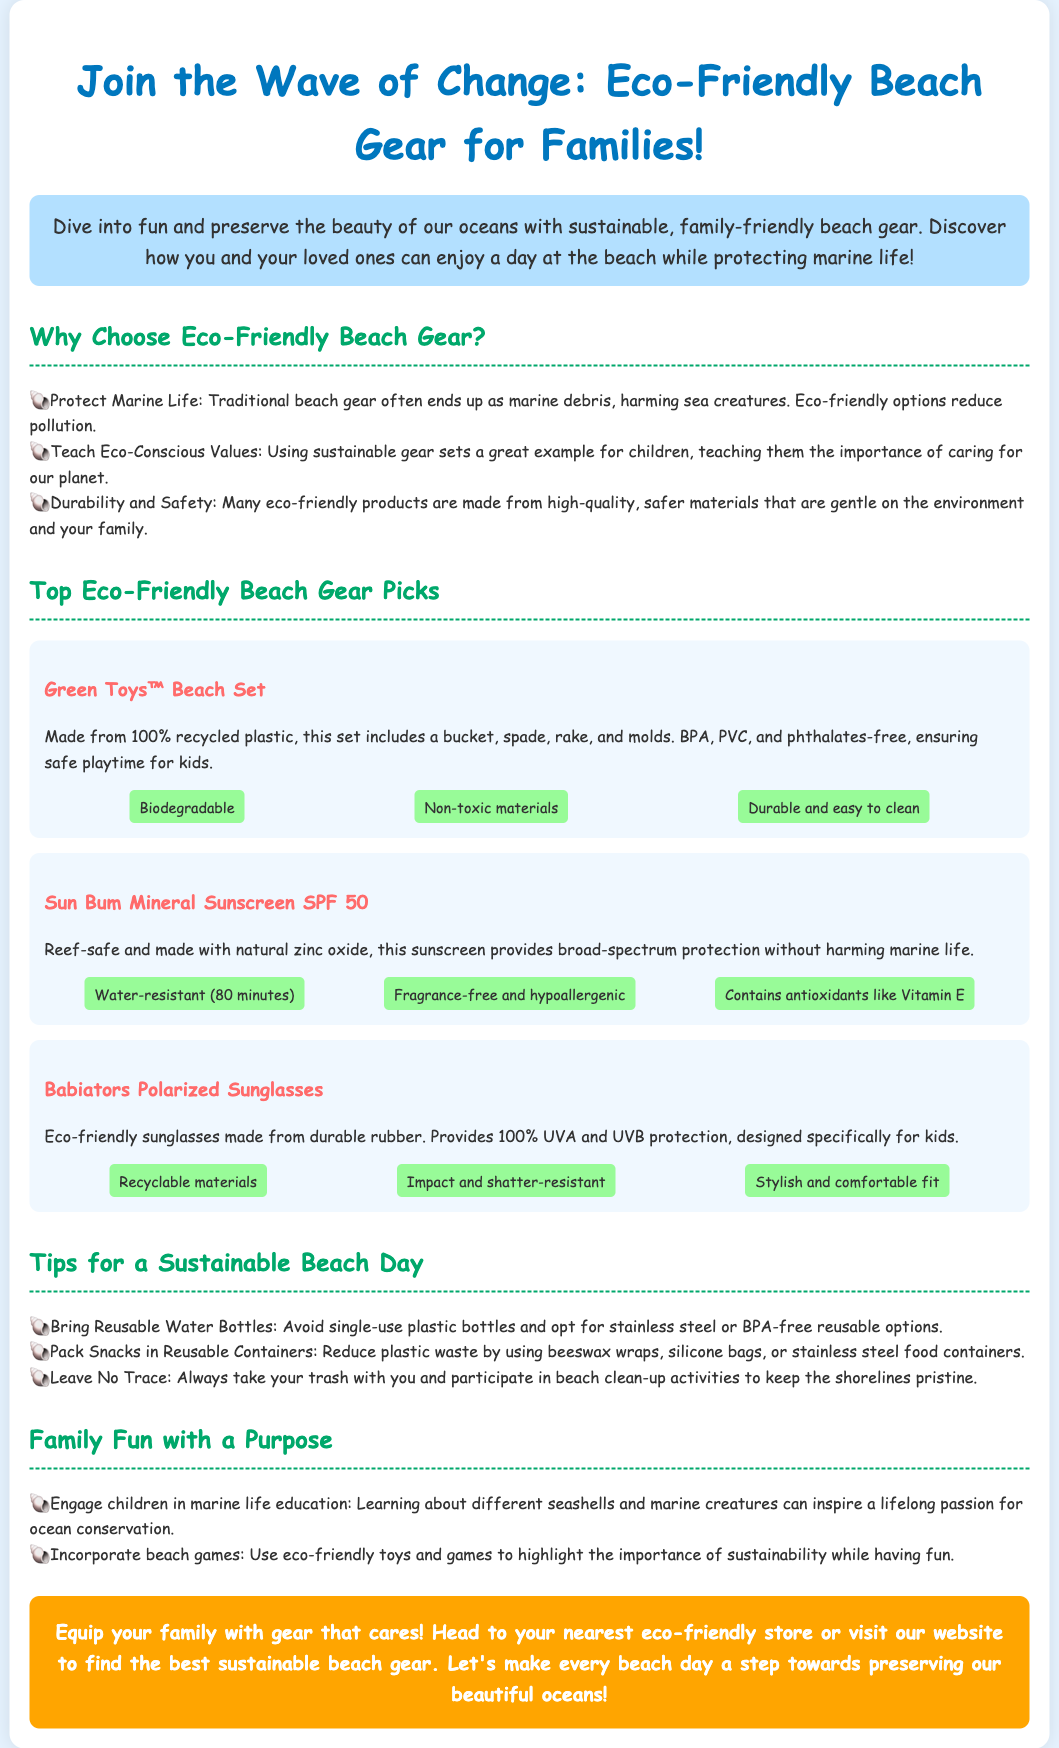What is the title of the advertisement? The title of the advertisement is found in the header and is specifically designed to grab attention regarding eco-friendly beach gear.
Answer: Eco-Friendly Beach Gear for Families What sunscreen is mentioned in the ad? The advertisement lists specific products, and this sunscreen is highlighted for its reef-safe quality.
Answer: Sun Bum Mineral Sunscreen SPF 50 How many benefits are listed for the Green Toys™ Beach Set? The benefits of the product are directly stated in the advertisement, specifically for this beach set.
Answer: Three What material are the Babiators Polarized Sunglasses made from? The advertisement specifies the type of materials used in making the sunglasses.
Answer: Durable rubber What is one of the tips for a sustainable beach day? The document provides practical advice for families on how to engage in sustainable practices during their beach outings.
Answer: Bring Reusable Water Bottles Why should families choose eco-friendly beach gear? The document outlines several reasons for selecting eco-friendly options, focusing on their impact on the environment and teaching values.
Answer: Protect Marine Life What is the color of the call-to-action section? The advertisement designates a specific color for the call-to-action section to make it standout visually among the other sections.
Answer: Orange How long is the Sun Bum Mineral Sunscreen water-resistant? The amount of time the sunscreen remains effective when wet is specified in the product's benefits within the advertisement.
Answer: 80 minutes 